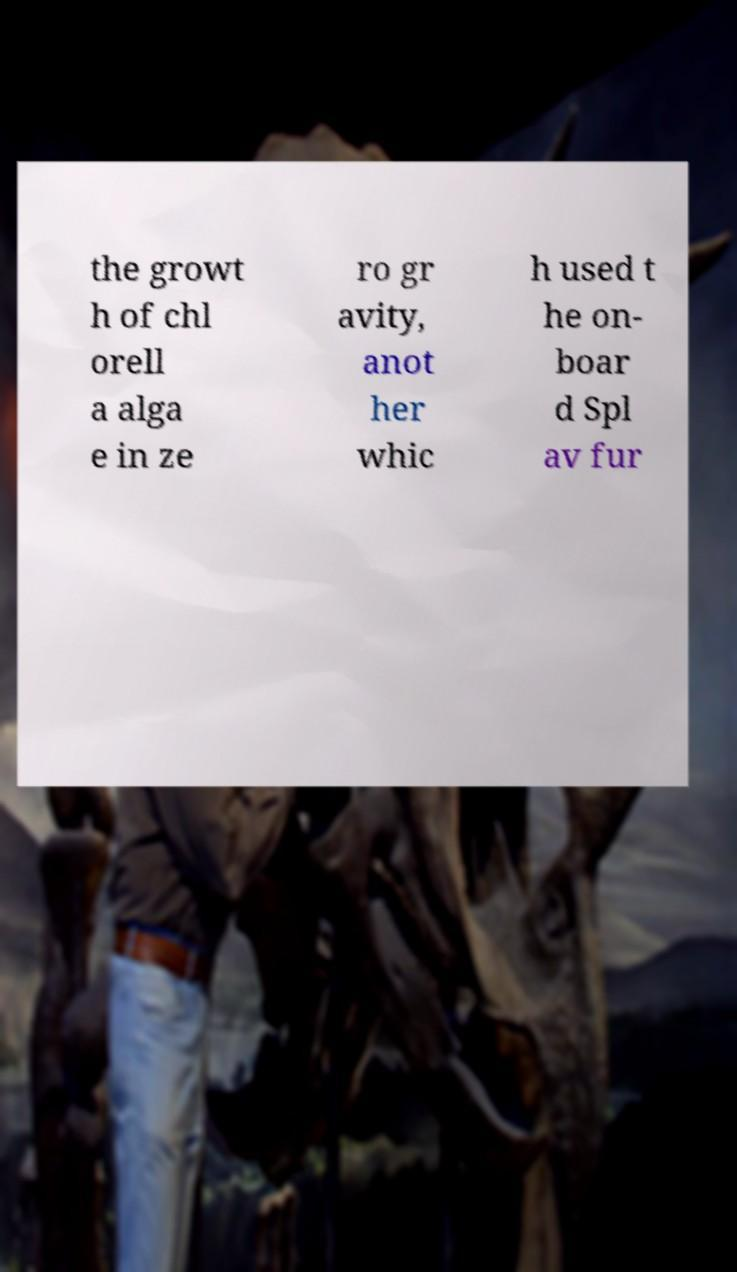Can you accurately transcribe the text from the provided image for me? the growt h of chl orell a alga e in ze ro gr avity, anot her whic h used t he on- boar d Spl av fur 